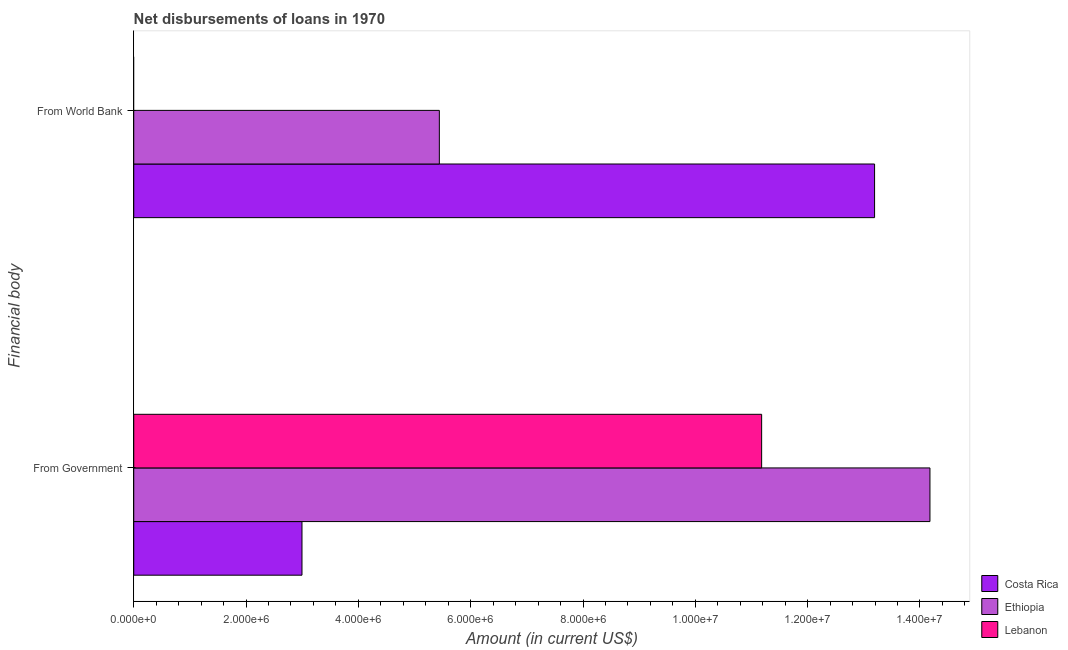How many different coloured bars are there?
Your response must be concise. 3. Are the number of bars per tick equal to the number of legend labels?
Make the answer very short. No. How many bars are there on the 2nd tick from the top?
Provide a short and direct response. 3. How many bars are there on the 1st tick from the bottom?
Provide a succinct answer. 3. What is the label of the 1st group of bars from the top?
Give a very brief answer. From World Bank. What is the net disbursements of loan from world bank in Lebanon?
Offer a very short reply. 0. Across all countries, what is the maximum net disbursements of loan from world bank?
Make the answer very short. 1.32e+07. Across all countries, what is the minimum net disbursements of loan from government?
Your answer should be very brief. 3.00e+06. In which country was the net disbursements of loan from government maximum?
Offer a very short reply. Ethiopia. What is the total net disbursements of loan from government in the graph?
Your answer should be compact. 2.84e+07. What is the difference between the net disbursements of loan from world bank in Ethiopia and that in Costa Rica?
Keep it short and to the point. -7.75e+06. What is the difference between the net disbursements of loan from world bank in Ethiopia and the net disbursements of loan from government in Costa Rica?
Offer a terse response. 2.45e+06. What is the average net disbursements of loan from government per country?
Ensure brevity in your answer.  9.45e+06. What is the difference between the net disbursements of loan from government and net disbursements of loan from world bank in Ethiopia?
Give a very brief answer. 8.74e+06. What is the ratio of the net disbursements of loan from government in Costa Rica to that in Lebanon?
Keep it short and to the point. 0.27. Is the net disbursements of loan from government in Costa Rica less than that in Lebanon?
Make the answer very short. Yes. Are all the bars in the graph horizontal?
Provide a short and direct response. Yes. Does the graph contain any zero values?
Ensure brevity in your answer.  Yes. Where does the legend appear in the graph?
Provide a succinct answer. Bottom right. How are the legend labels stacked?
Your answer should be very brief. Vertical. What is the title of the graph?
Offer a terse response. Net disbursements of loans in 1970. Does "Small states" appear as one of the legend labels in the graph?
Provide a succinct answer. No. What is the label or title of the Y-axis?
Offer a very short reply. Financial body. What is the Amount (in current US$) in Costa Rica in From Government?
Provide a succinct answer. 3.00e+06. What is the Amount (in current US$) in Ethiopia in From Government?
Ensure brevity in your answer.  1.42e+07. What is the Amount (in current US$) of Lebanon in From Government?
Your answer should be compact. 1.12e+07. What is the Amount (in current US$) of Costa Rica in From World Bank?
Your answer should be very brief. 1.32e+07. What is the Amount (in current US$) in Ethiopia in From World Bank?
Offer a terse response. 5.44e+06. What is the Amount (in current US$) in Lebanon in From World Bank?
Offer a very short reply. 0. Across all Financial body, what is the maximum Amount (in current US$) of Costa Rica?
Your response must be concise. 1.32e+07. Across all Financial body, what is the maximum Amount (in current US$) of Ethiopia?
Provide a short and direct response. 1.42e+07. Across all Financial body, what is the maximum Amount (in current US$) of Lebanon?
Offer a terse response. 1.12e+07. Across all Financial body, what is the minimum Amount (in current US$) in Costa Rica?
Your answer should be compact. 3.00e+06. Across all Financial body, what is the minimum Amount (in current US$) of Ethiopia?
Give a very brief answer. 5.44e+06. Across all Financial body, what is the minimum Amount (in current US$) of Lebanon?
Offer a very short reply. 0. What is the total Amount (in current US$) of Costa Rica in the graph?
Offer a very short reply. 1.62e+07. What is the total Amount (in current US$) in Ethiopia in the graph?
Ensure brevity in your answer.  1.96e+07. What is the total Amount (in current US$) in Lebanon in the graph?
Provide a succinct answer. 1.12e+07. What is the difference between the Amount (in current US$) in Costa Rica in From Government and that in From World Bank?
Provide a succinct answer. -1.02e+07. What is the difference between the Amount (in current US$) in Ethiopia in From Government and that in From World Bank?
Your answer should be compact. 8.74e+06. What is the difference between the Amount (in current US$) in Costa Rica in From Government and the Amount (in current US$) in Ethiopia in From World Bank?
Your answer should be compact. -2.45e+06. What is the average Amount (in current US$) of Costa Rica per Financial body?
Offer a very short reply. 8.09e+06. What is the average Amount (in current US$) of Ethiopia per Financial body?
Make the answer very short. 9.81e+06. What is the average Amount (in current US$) of Lebanon per Financial body?
Your response must be concise. 5.59e+06. What is the difference between the Amount (in current US$) in Costa Rica and Amount (in current US$) in Ethiopia in From Government?
Give a very brief answer. -1.12e+07. What is the difference between the Amount (in current US$) of Costa Rica and Amount (in current US$) of Lebanon in From Government?
Ensure brevity in your answer.  -8.18e+06. What is the difference between the Amount (in current US$) of Ethiopia and Amount (in current US$) of Lebanon in From Government?
Offer a very short reply. 3.00e+06. What is the difference between the Amount (in current US$) of Costa Rica and Amount (in current US$) of Ethiopia in From World Bank?
Your response must be concise. 7.75e+06. What is the ratio of the Amount (in current US$) of Costa Rica in From Government to that in From World Bank?
Give a very brief answer. 0.23. What is the ratio of the Amount (in current US$) in Ethiopia in From Government to that in From World Bank?
Provide a succinct answer. 2.61. What is the difference between the highest and the second highest Amount (in current US$) of Costa Rica?
Provide a short and direct response. 1.02e+07. What is the difference between the highest and the second highest Amount (in current US$) of Ethiopia?
Give a very brief answer. 8.74e+06. What is the difference between the highest and the lowest Amount (in current US$) of Costa Rica?
Your response must be concise. 1.02e+07. What is the difference between the highest and the lowest Amount (in current US$) in Ethiopia?
Your response must be concise. 8.74e+06. What is the difference between the highest and the lowest Amount (in current US$) in Lebanon?
Your answer should be compact. 1.12e+07. 